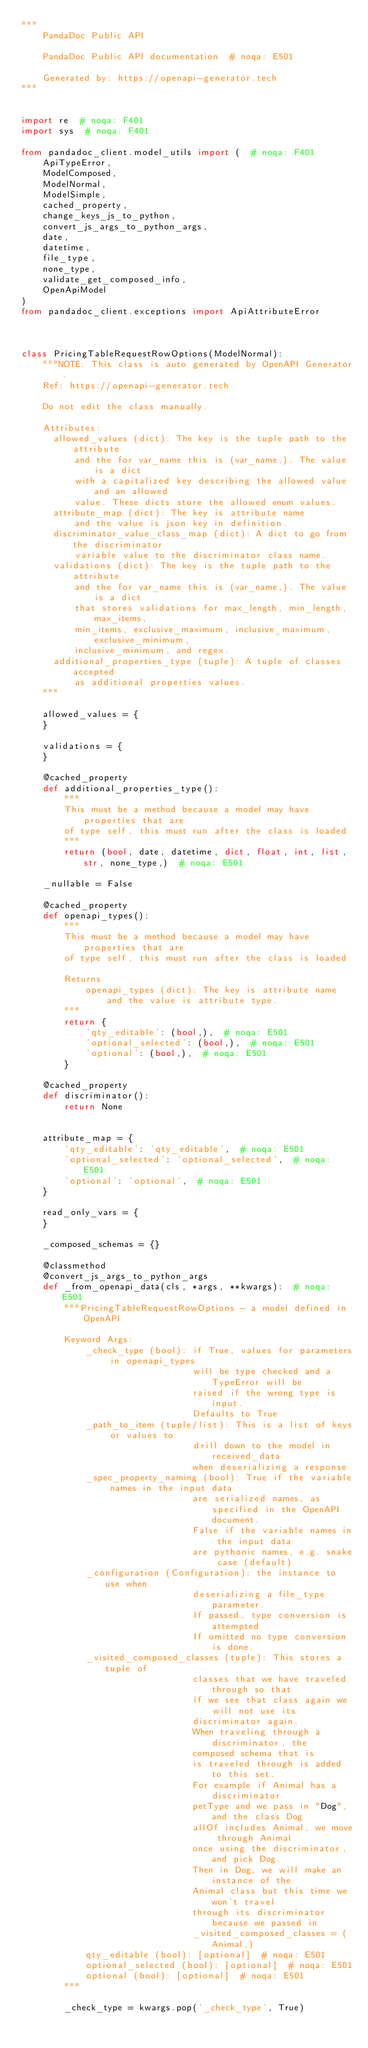<code> <loc_0><loc_0><loc_500><loc_500><_Python_>"""
    PandaDoc Public API

    PandaDoc Public API documentation  # noqa: E501

    Generated by: https://openapi-generator.tech
"""


import re  # noqa: F401
import sys  # noqa: F401

from pandadoc_client.model_utils import (  # noqa: F401
    ApiTypeError,
    ModelComposed,
    ModelNormal,
    ModelSimple,
    cached_property,
    change_keys_js_to_python,
    convert_js_args_to_python_args,
    date,
    datetime,
    file_type,
    none_type,
    validate_get_composed_info,
    OpenApiModel
)
from pandadoc_client.exceptions import ApiAttributeError



class PricingTableRequestRowOptions(ModelNormal):
    """NOTE: This class is auto generated by OpenAPI Generator.
    Ref: https://openapi-generator.tech

    Do not edit the class manually.

    Attributes:
      allowed_values (dict): The key is the tuple path to the attribute
          and the for var_name this is (var_name,). The value is a dict
          with a capitalized key describing the allowed value and an allowed
          value. These dicts store the allowed enum values.
      attribute_map (dict): The key is attribute name
          and the value is json key in definition.
      discriminator_value_class_map (dict): A dict to go from the discriminator
          variable value to the discriminator class name.
      validations (dict): The key is the tuple path to the attribute
          and the for var_name this is (var_name,). The value is a dict
          that stores validations for max_length, min_length, max_items,
          min_items, exclusive_maximum, inclusive_maximum, exclusive_minimum,
          inclusive_minimum, and regex.
      additional_properties_type (tuple): A tuple of classes accepted
          as additional properties values.
    """

    allowed_values = {
    }

    validations = {
    }

    @cached_property
    def additional_properties_type():
        """
        This must be a method because a model may have properties that are
        of type self, this must run after the class is loaded
        """
        return (bool, date, datetime, dict, float, int, list, str, none_type,)  # noqa: E501

    _nullable = False

    @cached_property
    def openapi_types():
        """
        This must be a method because a model may have properties that are
        of type self, this must run after the class is loaded

        Returns
            openapi_types (dict): The key is attribute name
                and the value is attribute type.
        """
        return {
            'qty_editable': (bool,),  # noqa: E501
            'optional_selected': (bool,),  # noqa: E501
            'optional': (bool,),  # noqa: E501
        }

    @cached_property
    def discriminator():
        return None


    attribute_map = {
        'qty_editable': 'qty_editable',  # noqa: E501
        'optional_selected': 'optional_selected',  # noqa: E501
        'optional': 'optional',  # noqa: E501
    }

    read_only_vars = {
    }

    _composed_schemas = {}

    @classmethod
    @convert_js_args_to_python_args
    def _from_openapi_data(cls, *args, **kwargs):  # noqa: E501
        """PricingTableRequestRowOptions - a model defined in OpenAPI

        Keyword Args:
            _check_type (bool): if True, values for parameters in openapi_types
                                will be type checked and a TypeError will be
                                raised if the wrong type is input.
                                Defaults to True
            _path_to_item (tuple/list): This is a list of keys or values to
                                drill down to the model in received_data
                                when deserializing a response
            _spec_property_naming (bool): True if the variable names in the input data
                                are serialized names, as specified in the OpenAPI document.
                                False if the variable names in the input data
                                are pythonic names, e.g. snake case (default)
            _configuration (Configuration): the instance to use when
                                deserializing a file_type parameter.
                                If passed, type conversion is attempted
                                If omitted no type conversion is done.
            _visited_composed_classes (tuple): This stores a tuple of
                                classes that we have traveled through so that
                                if we see that class again we will not use its
                                discriminator again.
                                When traveling through a discriminator, the
                                composed schema that is
                                is traveled through is added to this set.
                                For example if Animal has a discriminator
                                petType and we pass in "Dog", and the class Dog
                                allOf includes Animal, we move through Animal
                                once using the discriminator, and pick Dog.
                                Then in Dog, we will make an instance of the
                                Animal class but this time we won't travel
                                through its discriminator because we passed in
                                _visited_composed_classes = (Animal,)
            qty_editable (bool): [optional]  # noqa: E501
            optional_selected (bool): [optional]  # noqa: E501
            optional (bool): [optional]  # noqa: E501
        """

        _check_type = kwargs.pop('_check_type', True)</code> 